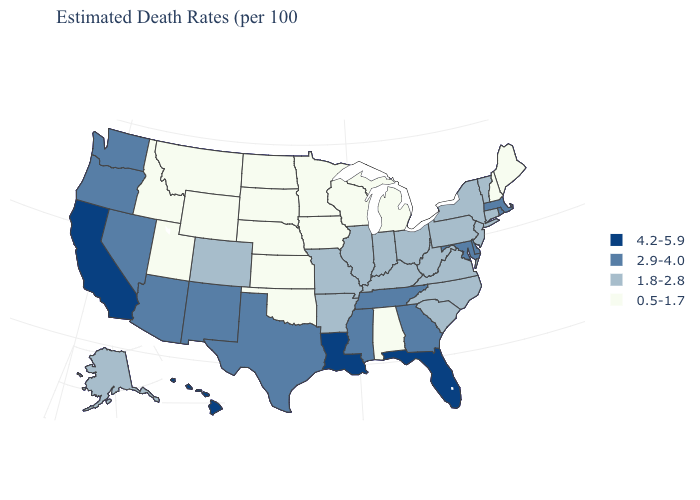Does Ohio have the highest value in the MidWest?
Keep it brief. Yes. Does Wyoming have the lowest value in the USA?
Quick response, please. Yes. Which states have the lowest value in the USA?
Write a very short answer. Alabama, Idaho, Iowa, Kansas, Maine, Michigan, Minnesota, Montana, Nebraska, New Hampshire, North Dakota, Oklahoma, South Dakota, Utah, Wisconsin, Wyoming. What is the value of Connecticut?
Be succinct. 1.8-2.8. Does the first symbol in the legend represent the smallest category?
Concise answer only. No. Among the states that border Delaware , does New Jersey have the lowest value?
Give a very brief answer. Yes. Which states have the highest value in the USA?
Short answer required. California, Florida, Hawaii, Louisiana. What is the value of Montana?
Give a very brief answer. 0.5-1.7. What is the highest value in the West ?
Be succinct. 4.2-5.9. Name the states that have a value in the range 1.8-2.8?
Quick response, please. Alaska, Arkansas, Colorado, Connecticut, Illinois, Indiana, Kentucky, Missouri, New Jersey, New York, North Carolina, Ohio, Pennsylvania, South Carolina, Vermont, Virginia, West Virginia. Name the states that have a value in the range 1.8-2.8?
Answer briefly. Alaska, Arkansas, Colorado, Connecticut, Illinois, Indiana, Kentucky, Missouri, New Jersey, New York, North Carolina, Ohio, Pennsylvania, South Carolina, Vermont, Virginia, West Virginia. What is the value of Illinois?
Short answer required. 1.8-2.8. Name the states that have a value in the range 2.9-4.0?
Concise answer only. Arizona, Delaware, Georgia, Maryland, Massachusetts, Mississippi, Nevada, New Mexico, Oregon, Rhode Island, Tennessee, Texas, Washington. Name the states that have a value in the range 0.5-1.7?
Answer briefly. Alabama, Idaho, Iowa, Kansas, Maine, Michigan, Minnesota, Montana, Nebraska, New Hampshire, North Dakota, Oklahoma, South Dakota, Utah, Wisconsin, Wyoming. Does the map have missing data?
Give a very brief answer. No. 